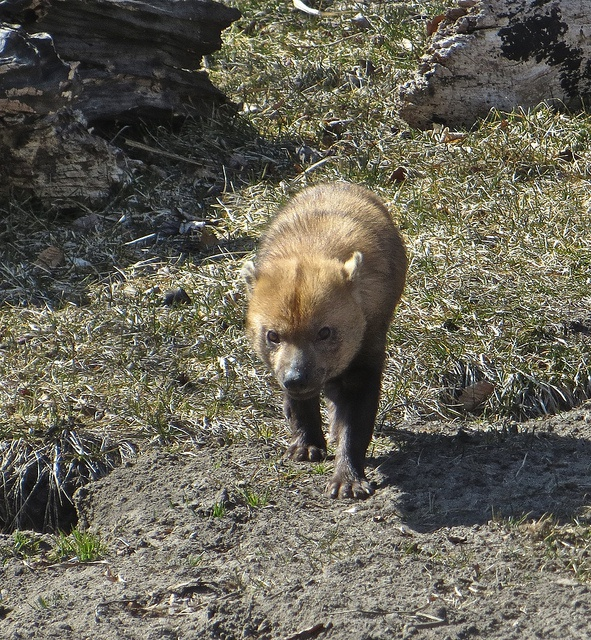Describe the objects in this image and their specific colors. I can see a bear in darkblue, black, gray, and tan tones in this image. 